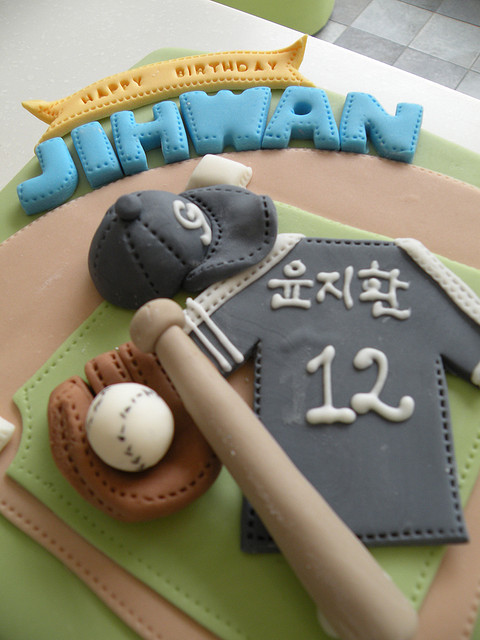Read all the text in this image. 12 jihwan HAPPY BIRTHDAY 